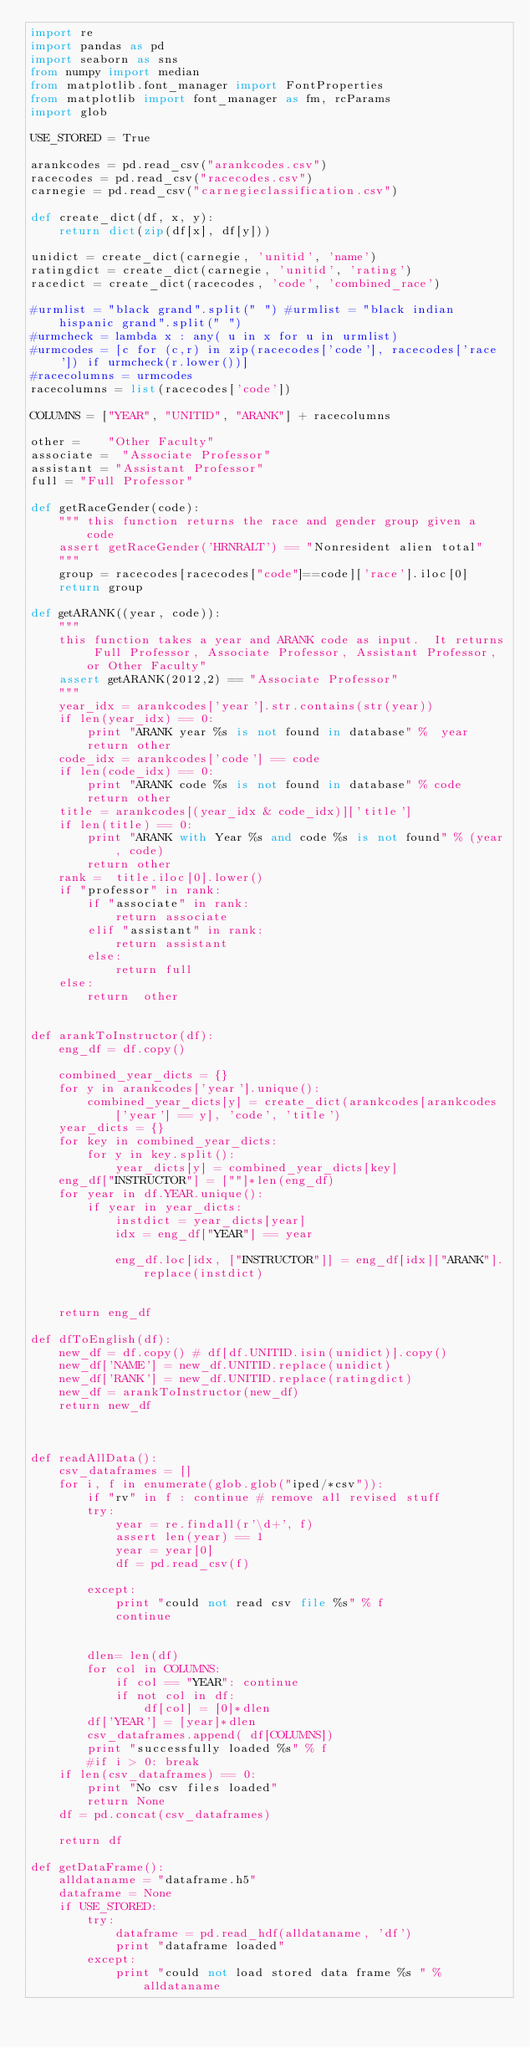Convert code to text. <code><loc_0><loc_0><loc_500><loc_500><_Python_>import re
import pandas as pd
import seaborn as sns
from numpy import median
from matplotlib.font_manager import FontProperties
from matplotlib import font_manager as fm, rcParams
import glob

USE_STORED = True

arankcodes = pd.read_csv("arankcodes.csv")
racecodes = pd.read_csv("racecodes.csv")
carnegie = pd.read_csv("carnegieclassification.csv")

def create_dict(df, x, y):
    return dict(zip(df[x], df[y]))

unidict = create_dict(carnegie, 'unitid', 'name')
ratingdict = create_dict(carnegie, 'unitid', 'rating')
racedict = create_dict(racecodes, 'code', 'combined_race')

#urmlist = "black grand".split(" ") #urmlist = "black indian hispanic grand".split(" ")
#urmcheck = lambda x : any( u in x for u in urmlist)
#urmcodes = [c for (c,r) in zip(racecodes['code'], racecodes['race']) if urmcheck(r.lower())]
#racecolumns = urmcodes  
racecolumns = list(racecodes['code'])

COLUMNS = ["YEAR", "UNITID", "ARANK"] + racecolumns 

other =    "Other Faculty"
associate =  "Associate Professor"
assistant = "Assistant Professor"
full = "Full Professor"

def getRaceGender(code):
    """ this function returns the race and gender group given a code
    assert getRaceGender('HRNRALT') == "Nonresident alien total"
    """
    group = racecodes[racecodes["code"]==code]['race'].iloc[0]
    return group

def getARANK((year, code)):
    """
    this function takes a year and ARANK code as input.  It returns Full Professor, Associate Professor, Assistant Professor, or Other Faculty"
    assert getARANK(2012,2) == "Associate Professor"
    """
    year_idx = arankcodes['year'].str.contains(str(year))
    if len(year_idx) == 0: 
        print "ARANK year %s is not found in database" %  year
        return other
    code_idx = arankcodes['code'] == code
    if len(code_idx) == 0:
        print "ARANK code %s is not found in database" % code
        return other
    title = arankcodes[(year_idx & code_idx)]['title']
    if len(title) == 0:
        print "ARANK with Year %s and code %s is not found" % (year, code)
        return other
    rank =  title.iloc[0].lower()
    if "professor" in rank:
        if "associate" in rank:
            return associate
        elif "assistant" in rank: 
            return assistant
        else:
            return full
    else:
        return  other


def arankToInstructor(df):
    eng_df = df.copy()

    combined_year_dicts = {}
    for y in arankcodes['year'].unique():
        combined_year_dicts[y] = create_dict(arankcodes[arankcodes['year'] == y], 'code', 'title')
    year_dicts = {}
    for key in combined_year_dicts:
        for y in key.split():
            year_dicts[y] = combined_year_dicts[key]
    eng_df["INSTRUCTOR"] = [""]*len(eng_df)
    for year in df.YEAR.unique():
        if year in year_dicts:
            instdict = year_dicts[year]
            idx = eng_df["YEAR"] == year

            eng_df.loc[idx, ["INSTRUCTOR"]] = eng_df[idx]["ARANK"].replace(instdict)

        
    return eng_df

def dfToEnglish(df):
    new_df = df.copy() # df[df.UNITID.isin(unidict)].copy()
    new_df['NAME'] = new_df.UNITID.replace(unidict)
    new_df['RANK'] = new_df.UNITID.replace(ratingdict)
    new_df = arankToInstructor(new_df)
    return new_df



def readAllData():
    csv_dataframes = []
    for i, f in enumerate(glob.glob("iped/*csv")):
        if "rv" in f : continue # remove all revised stuff
        try:
            year = re.findall(r'\d+', f)
            assert len(year) == 1
            year = year[0]
            df = pd.read_csv(f)

        except:
            print "could not read csv file %s" % f
            continue

        
        dlen= len(df)
        for col in COLUMNS:
            if col == "YEAR": continue
            if not col in df:
                df[col] = [0]*dlen
        df['YEAR'] = [year]*dlen
        csv_dataframes.append( df[COLUMNS])
        print "successfully loaded %s" % f
        #if i > 0: break
    if len(csv_dataframes) == 0:
        print "No csv files loaded"
        return None
    df = pd.concat(csv_dataframes)
    
    return df

def getDataFrame():
    alldataname = "dataframe.h5"
    dataframe = None
    if USE_STORED:
        try:
            dataframe = pd.read_hdf(alldataname, 'df')
            print "dataframe loaded"
        except:
            print "could not load stored data frame %s " % alldataname
</code> 